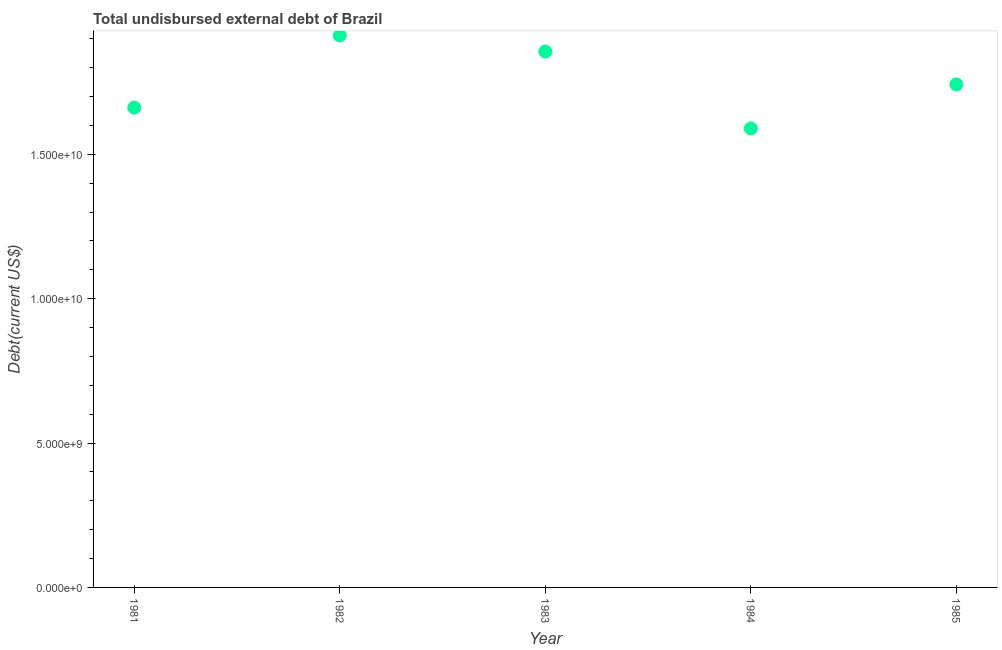What is the total debt in 1984?
Ensure brevity in your answer.  1.59e+1. Across all years, what is the maximum total debt?
Your answer should be compact. 1.91e+1. Across all years, what is the minimum total debt?
Your answer should be compact. 1.59e+1. In which year was the total debt maximum?
Keep it short and to the point. 1982. In which year was the total debt minimum?
Provide a short and direct response. 1984. What is the sum of the total debt?
Provide a short and direct response. 8.76e+1. What is the difference between the total debt in 1981 and 1984?
Your answer should be very brief. 7.22e+08. What is the average total debt per year?
Provide a succinct answer. 1.75e+1. What is the median total debt?
Ensure brevity in your answer.  1.74e+1. Do a majority of the years between 1982 and 1984 (inclusive) have total debt greater than 9000000000 US$?
Provide a succinct answer. Yes. What is the ratio of the total debt in 1983 to that in 1985?
Provide a short and direct response. 1.07. Is the total debt in 1981 less than that in 1982?
Your response must be concise. Yes. Is the difference between the total debt in 1982 and 1985 greater than the difference between any two years?
Provide a succinct answer. No. What is the difference between the highest and the second highest total debt?
Offer a terse response. 5.58e+08. Is the sum of the total debt in 1982 and 1985 greater than the maximum total debt across all years?
Your response must be concise. Yes. What is the difference between the highest and the lowest total debt?
Your response must be concise. 3.22e+09. Does the total debt monotonically increase over the years?
Provide a short and direct response. No. Are the values on the major ticks of Y-axis written in scientific E-notation?
Give a very brief answer. Yes. Does the graph contain any zero values?
Offer a very short reply. No. What is the title of the graph?
Give a very brief answer. Total undisbursed external debt of Brazil. What is the label or title of the X-axis?
Ensure brevity in your answer.  Year. What is the label or title of the Y-axis?
Provide a succinct answer. Debt(current US$). What is the Debt(current US$) in 1981?
Offer a very short reply. 1.66e+1. What is the Debt(current US$) in 1982?
Give a very brief answer. 1.91e+1. What is the Debt(current US$) in 1983?
Keep it short and to the point. 1.86e+1. What is the Debt(current US$) in 1984?
Make the answer very short. 1.59e+1. What is the Debt(current US$) in 1985?
Provide a succinct answer. 1.74e+1. What is the difference between the Debt(current US$) in 1981 and 1982?
Your response must be concise. -2.50e+09. What is the difference between the Debt(current US$) in 1981 and 1983?
Provide a succinct answer. -1.94e+09. What is the difference between the Debt(current US$) in 1981 and 1984?
Provide a succinct answer. 7.22e+08. What is the difference between the Debt(current US$) in 1981 and 1985?
Ensure brevity in your answer.  -8.05e+08. What is the difference between the Debt(current US$) in 1982 and 1983?
Provide a succinct answer. 5.58e+08. What is the difference between the Debt(current US$) in 1982 and 1984?
Provide a succinct answer. 3.22e+09. What is the difference between the Debt(current US$) in 1982 and 1985?
Provide a short and direct response. 1.69e+09. What is the difference between the Debt(current US$) in 1983 and 1984?
Offer a very short reply. 2.66e+09. What is the difference between the Debt(current US$) in 1983 and 1985?
Give a very brief answer. 1.14e+09. What is the difference between the Debt(current US$) in 1984 and 1985?
Provide a short and direct response. -1.53e+09. What is the ratio of the Debt(current US$) in 1981 to that in 1982?
Make the answer very short. 0.87. What is the ratio of the Debt(current US$) in 1981 to that in 1983?
Provide a succinct answer. 0.9. What is the ratio of the Debt(current US$) in 1981 to that in 1984?
Provide a succinct answer. 1.04. What is the ratio of the Debt(current US$) in 1981 to that in 1985?
Your answer should be very brief. 0.95. What is the ratio of the Debt(current US$) in 1982 to that in 1984?
Provide a short and direct response. 1.2. What is the ratio of the Debt(current US$) in 1982 to that in 1985?
Your answer should be very brief. 1.1. What is the ratio of the Debt(current US$) in 1983 to that in 1984?
Provide a short and direct response. 1.17. What is the ratio of the Debt(current US$) in 1983 to that in 1985?
Offer a terse response. 1.06. What is the ratio of the Debt(current US$) in 1984 to that in 1985?
Keep it short and to the point. 0.91. 